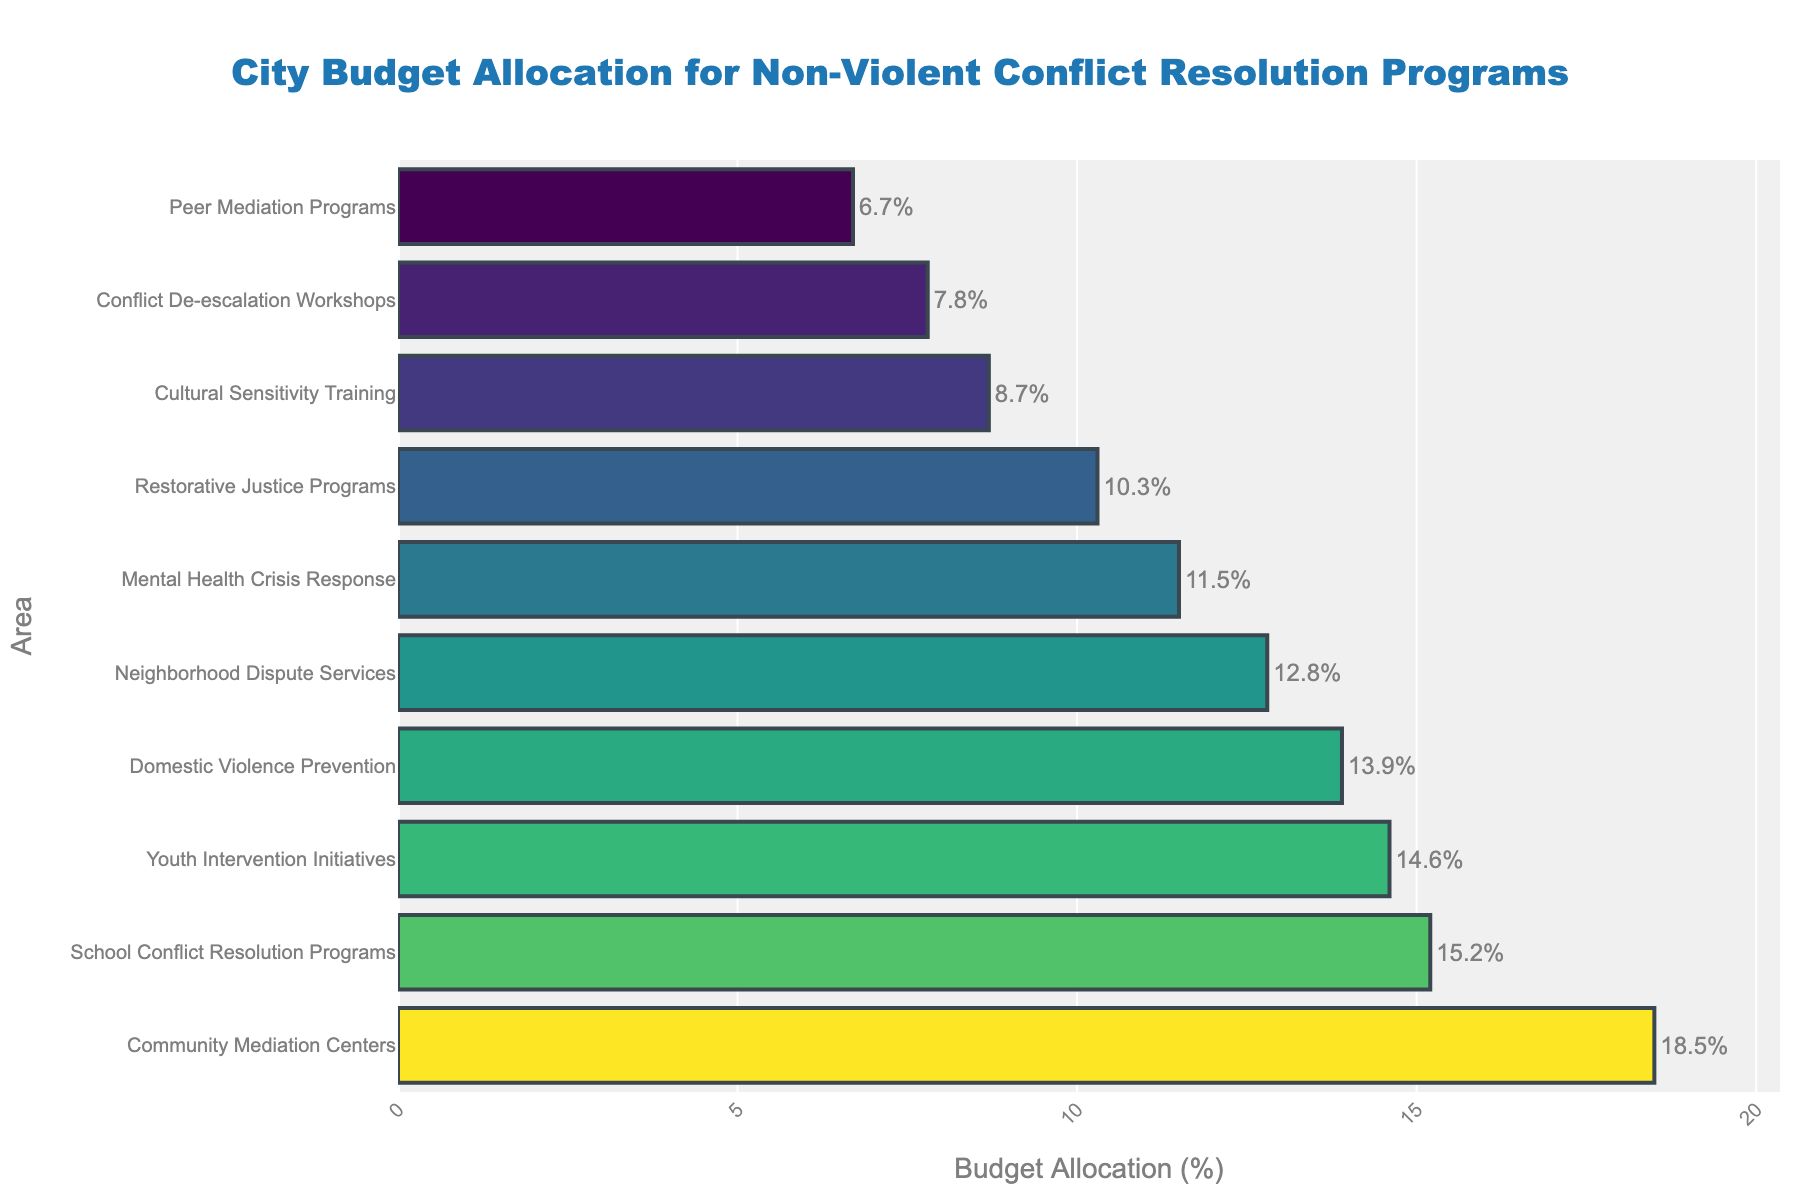What's the difference in budget allocation between Community Mediation Centers and Cultural Sensitivity Training? To find the difference in budget allocation, subtract the percentage allocated to Cultural Sensitivity Training from that allocated to Community Mediation Centers: 18.5% - 8.7% = 9.8%
Answer: 9.8% Which area receives the least amount of budget allocation? By looking at the length of the bars, we see that Peer Mediation Programs have the shortest bar, indicating that they receive the least amount of budget allocation at 6.7%.
Answer: Peer Mediation Programs What is the combined budget allocation for Youth Intervention Initiatives and Domestic Violence Prevention? To find the combined budget allocation, we add the percentages allocated to Youth Intervention Initiatives and Domestic Violence Prevention: 14.6% + 13.9% = 28.5%
Answer: 28.5% Which area receives a higher budget allocation: Neighborhood Dispute Services or Mental Health Crisis Response? Comparing the lengths of the bars, Neighborhood Dispute Services have a longer bar at 12.8%, whereas Mental Health Crisis Response has a shorter bar at 11.5%.
Answer: Neighborhood Dispute Services What's the total budget allocation for the top three areas? Summing the budget allocations of the top three areas: Community Mediation Centers (18.5%), School Conflict Resolution Programs (15.2%), and Youth Intervention Initiatives (14.6%): 18.5% + 15.2% + 14.6% = 48.3%
Answer: 48.3% What’s the average budget allocation for all areas? To find the average budget allocation, sum all the percentages and divide by the number of areas: (18.5 + 15.2 + 12.8 + 14.6 + 13.9 + 8.7 + 10.3 + 11.5 + 7.8 + 6.7) / 10 = 12%.
Answer: 12% Is the budget allocation for Restorative Justice Programs greater than for Cultural Sensitivity Training? Comparing the lengths of the bars, Restorative Justice Programs have a longer bar at 10.3%, while Cultural Sensitivity Training is at 8.7%.
Answer: Yes How much more budget allocation does School Conflict Resolution Programs receive compared to Peer Mediation Programs? Subtract the percentage allocated to Peer Mediation Programs from that allocated to School Conflict Resolution Programs: 15.2% - 6.7% = 8.5%
Answer: 8.5% 